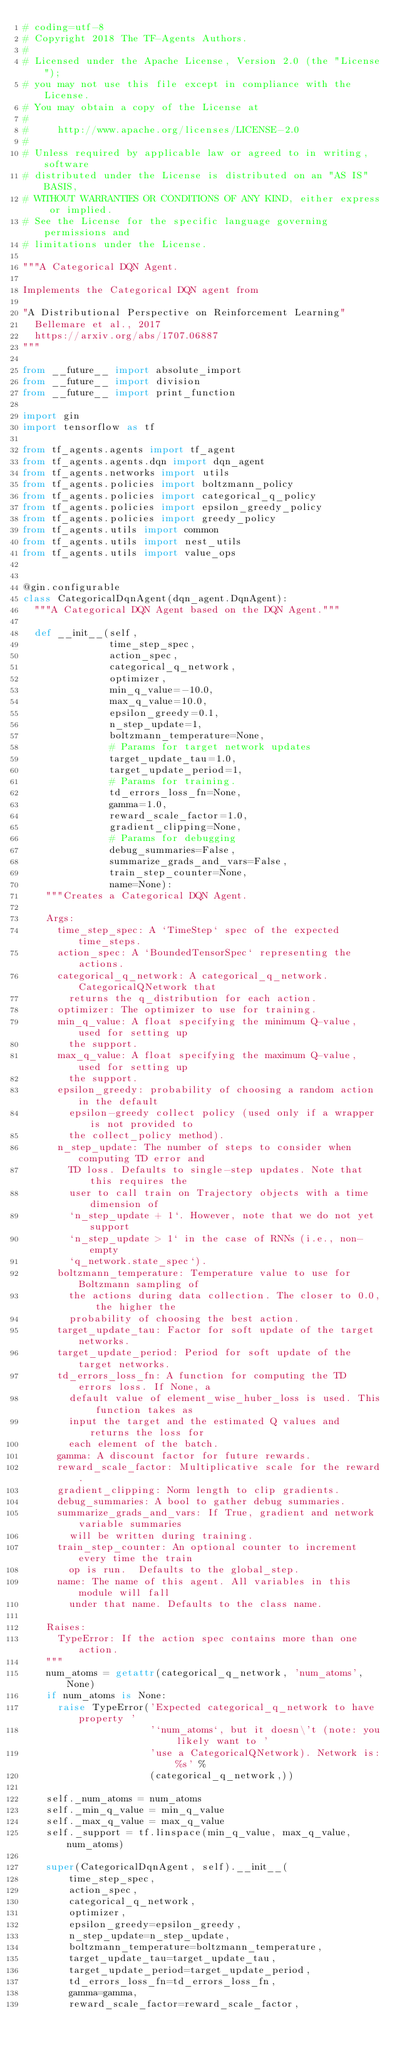<code> <loc_0><loc_0><loc_500><loc_500><_Python_># coding=utf-8
# Copyright 2018 The TF-Agents Authors.
#
# Licensed under the Apache License, Version 2.0 (the "License");
# you may not use this file except in compliance with the License.
# You may obtain a copy of the License at
#
#     http://www.apache.org/licenses/LICENSE-2.0
#
# Unless required by applicable law or agreed to in writing, software
# distributed under the License is distributed on an "AS IS" BASIS,
# WITHOUT WARRANTIES OR CONDITIONS OF ANY KIND, either express or implied.
# See the License for the specific language governing permissions and
# limitations under the License.

"""A Categorical DQN Agent.

Implements the Categorical DQN agent from

"A Distributional Perspective on Reinforcement Learning"
  Bellemare et al., 2017
  https://arxiv.org/abs/1707.06887
"""

from __future__ import absolute_import
from __future__ import division
from __future__ import print_function

import gin
import tensorflow as tf

from tf_agents.agents import tf_agent
from tf_agents.agents.dqn import dqn_agent
from tf_agents.networks import utils
from tf_agents.policies import boltzmann_policy
from tf_agents.policies import categorical_q_policy
from tf_agents.policies import epsilon_greedy_policy
from tf_agents.policies import greedy_policy
from tf_agents.utils import common
from tf_agents.utils import nest_utils
from tf_agents.utils import value_ops


@gin.configurable
class CategoricalDqnAgent(dqn_agent.DqnAgent):
  """A Categorical DQN Agent based on the DQN Agent."""

  def __init__(self,
               time_step_spec,
               action_spec,
               categorical_q_network,
               optimizer,
               min_q_value=-10.0,
               max_q_value=10.0,
               epsilon_greedy=0.1,
               n_step_update=1,
               boltzmann_temperature=None,
               # Params for target network updates
               target_update_tau=1.0,
               target_update_period=1,
               # Params for training.
               td_errors_loss_fn=None,
               gamma=1.0,
               reward_scale_factor=1.0,
               gradient_clipping=None,
               # Params for debugging
               debug_summaries=False,
               summarize_grads_and_vars=False,
               train_step_counter=None,
               name=None):
    """Creates a Categorical DQN Agent.

    Args:
      time_step_spec: A `TimeStep` spec of the expected time_steps.
      action_spec: A `BoundedTensorSpec` representing the actions.
      categorical_q_network: A categorical_q_network.CategoricalQNetwork that
        returns the q_distribution for each action.
      optimizer: The optimizer to use for training.
      min_q_value: A float specifying the minimum Q-value, used for setting up
        the support.
      max_q_value: A float specifying the maximum Q-value, used for setting up
        the support.
      epsilon_greedy: probability of choosing a random action in the default
        epsilon-greedy collect policy (used only if a wrapper is not provided to
        the collect_policy method).
      n_step_update: The number of steps to consider when computing TD error and
        TD loss. Defaults to single-step updates. Note that this requires the
        user to call train on Trajectory objects with a time dimension of
        `n_step_update + 1`. However, note that we do not yet support
        `n_step_update > 1` in the case of RNNs (i.e., non-empty
        `q_network.state_spec`).
      boltzmann_temperature: Temperature value to use for Boltzmann sampling of
        the actions during data collection. The closer to 0.0, the higher the
        probability of choosing the best action.
      target_update_tau: Factor for soft update of the target networks.
      target_update_period: Period for soft update of the target networks.
      td_errors_loss_fn: A function for computing the TD errors loss. If None, a
        default value of element_wise_huber_loss is used. This function takes as
        input the target and the estimated Q values and returns the loss for
        each element of the batch.
      gamma: A discount factor for future rewards.
      reward_scale_factor: Multiplicative scale for the reward.
      gradient_clipping: Norm length to clip gradients.
      debug_summaries: A bool to gather debug summaries.
      summarize_grads_and_vars: If True, gradient and network variable summaries
        will be written during training.
      train_step_counter: An optional counter to increment every time the train
        op is run.  Defaults to the global_step.
      name: The name of this agent. All variables in this module will fall
        under that name. Defaults to the class name.

    Raises:
      TypeError: If the action spec contains more than one action.
    """
    num_atoms = getattr(categorical_q_network, 'num_atoms', None)
    if num_atoms is None:
      raise TypeError('Expected categorical_q_network to have property '
                      '`num_atoms`, but it doesn\'t (note: you likely want to '
                      'use a CategoricalQNetwork). Network is: %s' %
                      (categorical_q_network,))

    self._num_atoms = num_atoms
    self._min_q_value = min_q_value
    self._max_q_value = max_q_value
    self._support = tf.linspace(min_q_value, max_q_value, num_atoms)

    super(CategoricalDqnAgent, self).__init__(
        time_step_spec,
        action_spec,
        categorical_q_network,
        optimizer,
        epsilon_greedy=epsilon_greedy,
        n_step_update=n_step_update,
        boltzmann_temperature=boltzmann_temperature,
        target_update_tau=target_update_tau,
        target_update_period=target_update_period,
        td_errors_loss_fn=td_errors_loss_fn,
        gamma=gamma,
        reward_scale_factor=reward_scale_factor,</code> 